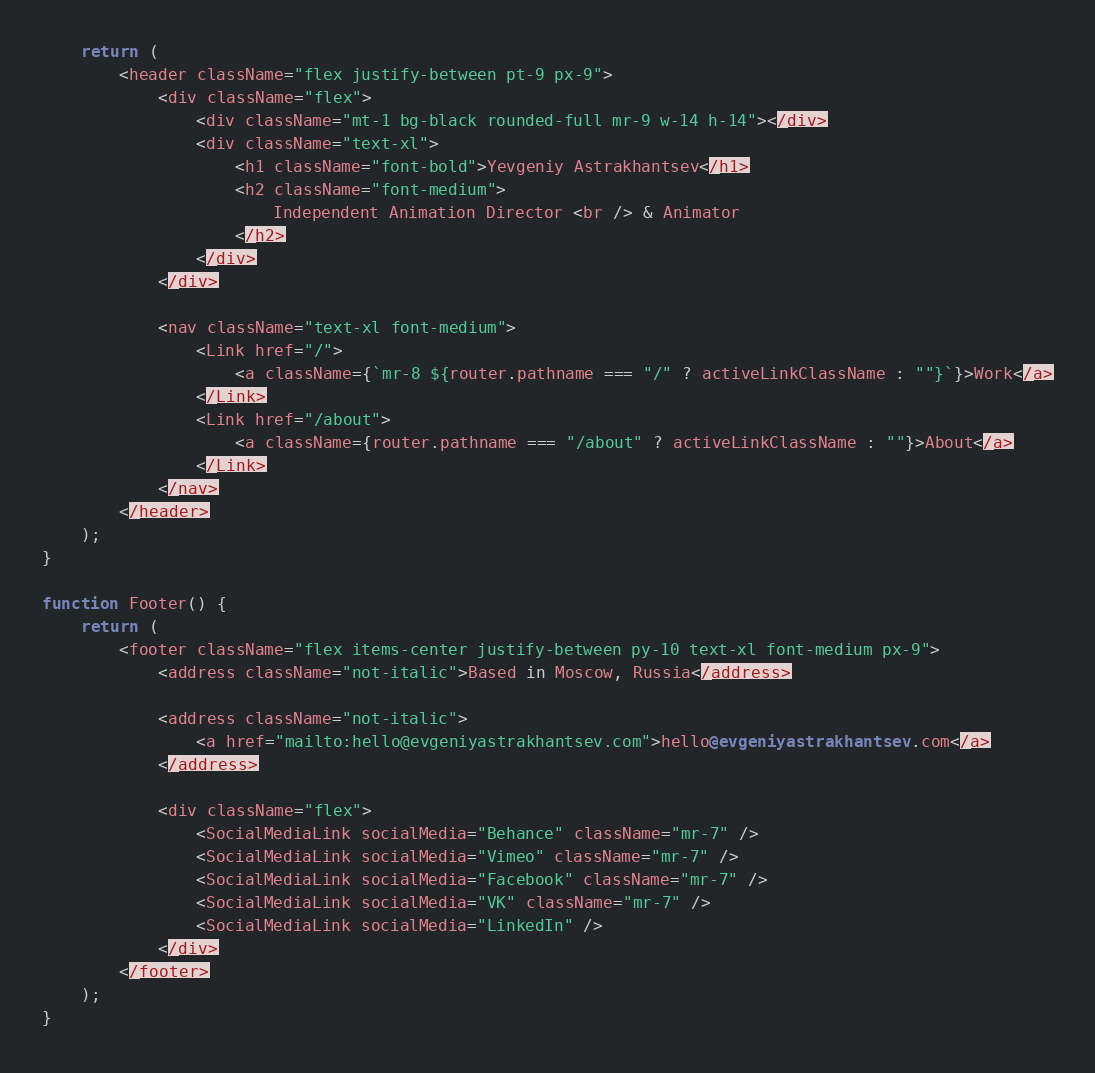Convert code to text. <code><loc_0><loc_0><loc_500><loc_500><_TypeScript_>	return (
		<header className="flex justify-between pt-9 px-9">
			<div className="flex">
				<div className="mt-1 bg-black rounded-full mr-9 w-14 h-14"></div>
				<div className="text-xl">
					<h1 className="font-bold">Yevgeniy Astrakhantsev</h1>
					<h2 className="font-medium">
						Independent Animation Director <br /> & Animator
					</h2>
				</div>
			</div>

			<nav className="text-xl font-medium">
				<Link href="/">
					<a className={`mr-8 ${router.pathname === "/" ? activeLinkClassName : ""}`}>Work</a>
				</Link>
				<Link href="/about">
					<a className={router.pathname === "/about" ? activeLinkClassName : ""}>About</a>
				</Link>
			</nav>
		</header>
	);
}

function Footer() {
	return (
		<footer className="flex items-center justify-between py-10 text-xl font-medium px-9">
			<address className="not-italic">Based in Moscow, Russia</address>

			<address className="not-italic">
				<a href="mailto:hello@evgeniyastrakhantsev.com">hello@evgeniyastrakhantsev.com</a>
			</address>

			<div className="flex">
				<SocialMediaLink socialMedia="Behance" className="mr-7" />
				<SocialMediaLink socialMedia="Vimeo" className="mr-7" />
				<SocialMediaLink socialMedia="Facebook" className="mr-7" />
				<SocialMediaLink socialMedia="VK" className="mr-7" />
				<SocialMediaLink socialMedia="LinkedIn" />
			</div>
		</footer>
	);
}
</code> 